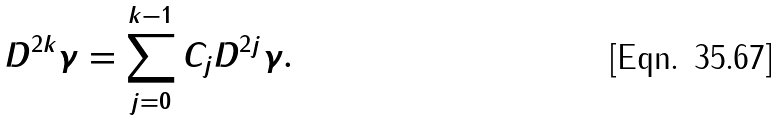Convert formula to latex. <formula><loc_0><loc_0><loc_500><loc_500>D ^ { 2 k } \gamma = \sum _ { j = 0 } ^ { k - 1 } C _ { j } D ^ { 2 j } \gamma .</formula> 